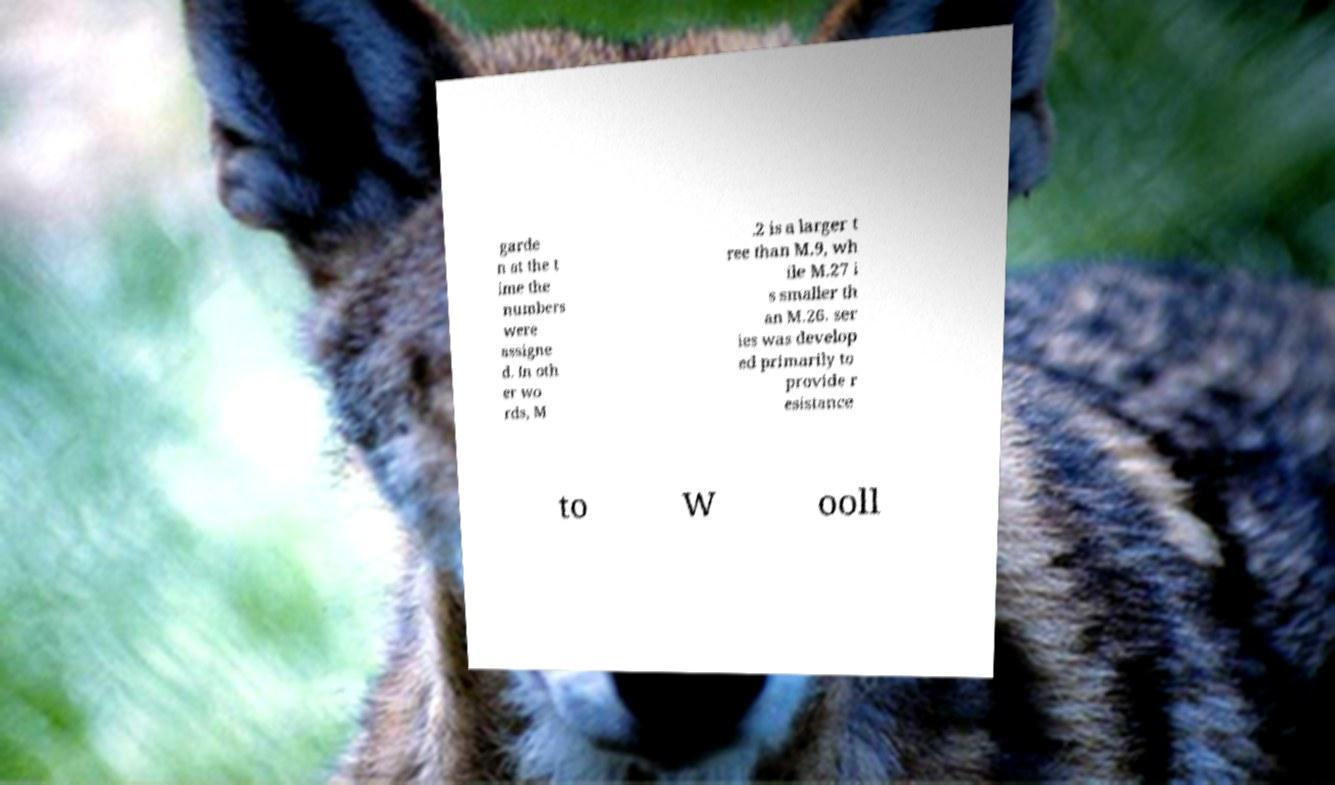I need the written content from this picture converted into text. Can you do that? garde n at the t ime the numbers were assigne d. In oth er wo rds, M .2 is a larger t ree than M.9, wh ile M.27 i s smaller th an M.26. ser ies was develop ed primarily to provide r esistance to W ooll 